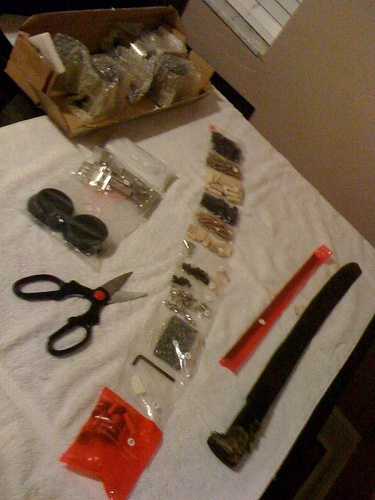Describe the objects in this image and their specific colors. I can see knife in black, darkgreen, and gray tones and scissors in black, darkgray, gray, and maroon tones in this image. 